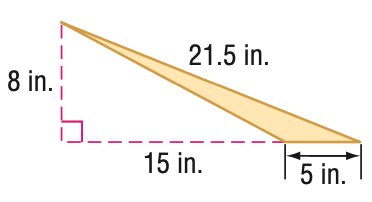Question: Find the area of the triangle. Round to the nearest tenth if necessary.
Choices:
A. 20
B. 40
C. 60
D. 80
Answer with the letter. Answer: A Question: Find the perimeter of the triangle. Round to the nearest tenth if necessary.
Choices:
A. 43.0
B. 43.5
C. 48.0
D. 49.5
Answer with the letter. Answer: B 